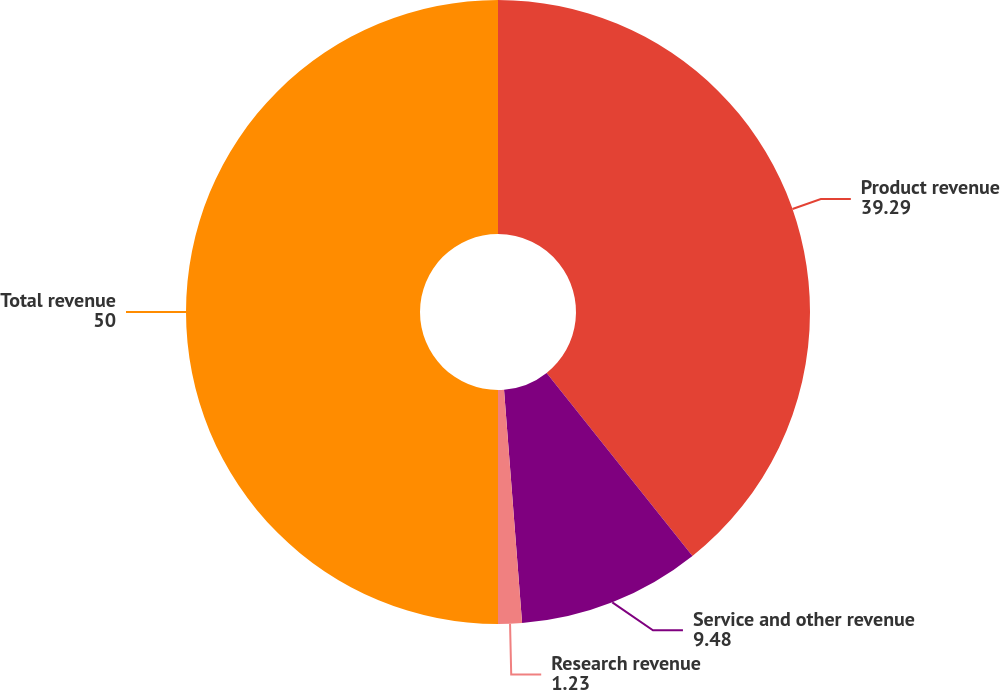<chart> <loc_0><loc_0><loc_500><loc_500><pie_chart><fcel>Product revenue<fcel>Service and other revenue<fcel>Research revenue<fcel>Total revenue<nl><fcel>39.29%<fcel>9.48%<fcel>1.23%<fcel>50.0%<nl></chart> 